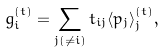<formula> <loc_0><loc_0><loc_500><loc_500>g ^ { ( t ) } _ { i } = \sum _ { j ( \neq i ) } t _ { i j } \langle p _ { j } \rangle _ { j } ^ { ( t ) } ,</formula> 